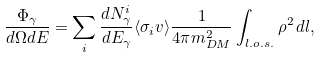Convert formula to latex. <formula><loc_0><loc_0><loc_500><loc_500>\frac { \Phi _ { \gamma } } { d \Omega d E } = \sum _ { i } \frac { d N ^ { i } _ { \gamma } } { d E _ { \gamma } } \langle \sigma _ { i } v \rangle \frac { 1 } { 4 \pi m _ { D M } ^ { 2 } } \int _ { l . o . s . } \rho ^ { 2 } \, d l ,</formula> 